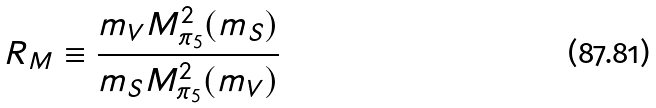Convert formula to latex. <formula><loc_0><loc_0><loc_500><loc_500>R _ { M } \equiv \frac { m _ { V } M ^ { 2 } _ { \pi _ { 5 } } ( m _ { S } ) } { m _ { S } M ^ { 2 } _ { \pi _ { 5 } } ( m _ { V } ) }</formula> 